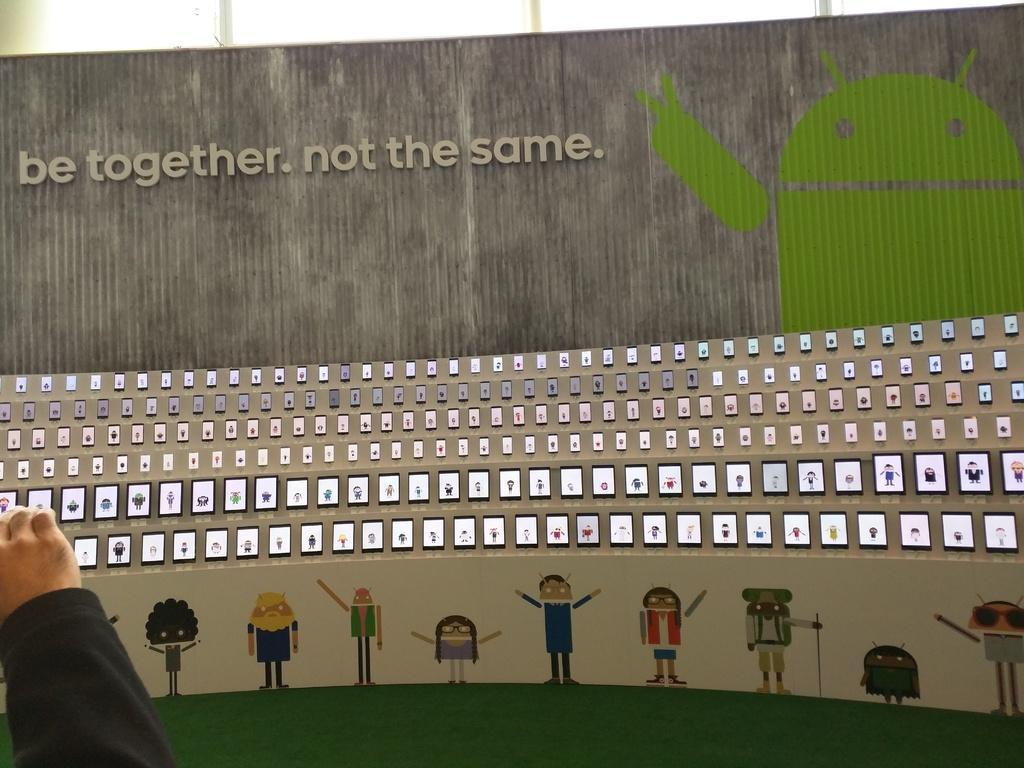Describe this image in one or two sentences. This image looks like a poster. In which there are many mobiles. At the bottom, there are cartoons. At the top, there is a text. On the left, there is a person standing. In the background, there is a wall. 